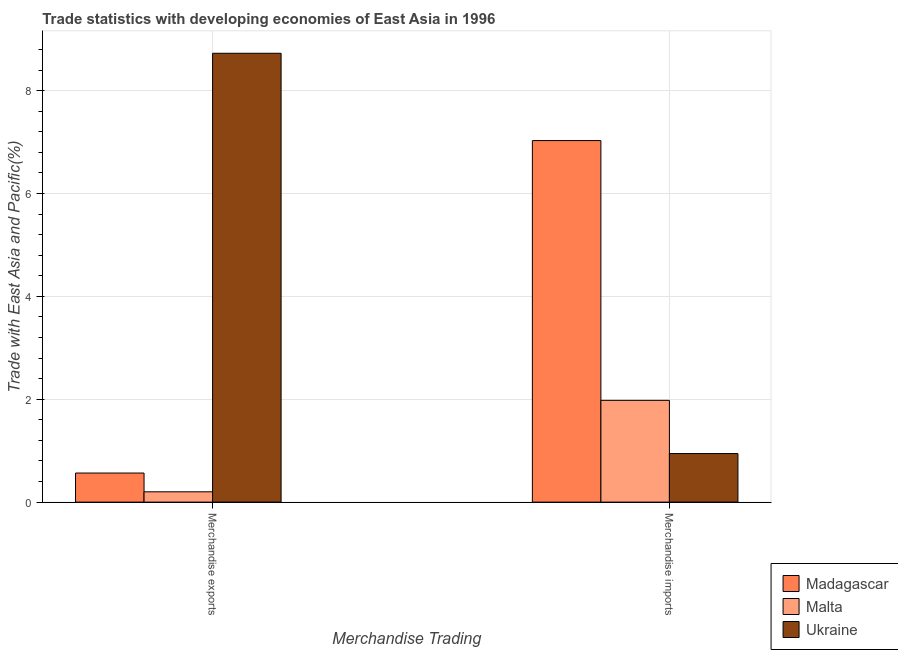How many groups of bars are there?
Offer a terse response. 2. What is the merchandise exports in Madagascar?
Offer a terse response. 0.57. Across all countries, what is the maximum merchandise imports?
Your response must be concise. 7.03. Across all countries, what is the minimum merchandise imports?
Your answer should be compact. 0.94. In which country was the merchandise imports maximum?
Make the answer very short. Madagascar. In which country was the merchandise imports minimum?
Make the answer very short. Ukraine. What is the total merchandise exports in the graph?
Offer a terse response. 9.49. What is the difference between the merchandise imports in Ukraine and that in Madagascar?
Your response must be concise. -6.09. What is the difference between the merchandise imports in Ukraine and the merchandise exports in Malta?
Provide a succinct answer. 0.74. What is the average merchandise imports per country?
Offer a terse response. 3.32. What is the difference between the merchandise imports and merchandise exports in Madagascar?
Provide a short and direct response. 6.46. What is the ratio of the merchandise exports in Ukraine to that in Madagascar?
Offer a terse response. 15.43. In how many countries, is the merchandise exports greater than the average merchandise exports taken over all countries?
Keep it short and to the point. 1. What does the 1st bar from the left in Merchandise imports represents?
Keep it short and to the point. Madagascar. What does the 3rd bar from the right in Merchandise exports represents?
Offer a very short reply. Madagascar. How many bars are there?
Provide a short and direct response. 6. How many countries are there in the graph?
Ensure brevity in your answer.  3. Are the values on the major ticks of Y-axis written in scientific E-notation?
Your answer should be compact. No. Does the graph contain grids?
Make the answer very short. Yes. Where does the legend appear in the graph?
Offer a very short reply. Bottom right. How are the legend labels stacked?
Offer a very short reply. Vertical. What is the title of the graph?
Keep it short and to the point. Trade statistics with developing economies of East Asia in 1996. What is the label or title of the X-axis?
Your answer should be compact. Merchandise Trading. What is the label or title of the Y-axis?
Provide a short and direct response. Trade with East Asia and Pacific(%). What is the Trade with East Asia and Pacific(%) in Madagascar in Merchandise exports?
Ensure brevity in your answer.  0.57. What is the Trade with East Asia and Pacific(%) in Malta in Merchandise exports?
Your answer should be very brief. 0.2. What is the Trade with East Asia and Pacific(%) of Ukraine in Merchandise exports?
Your response must be concise. 8.73. What is the Trade with East Asia and Pacific(%) in Madagascar in Merchandise imports?
Provide a succinct answer. 7.03. What is the Trade with East Asia and Pacific(%) in Malta in Merchandise imports?
Provide a succinct answer. 1.98. What is the Trade with East Asia and Pacific(%) of Ukraine in Merchandise imports?
Your response must be concise. 0.94. Across all Merchandise Trading, what is the maximum Trade with East Asia and Pacific(%) of Madagascar?
Your answer should be very brief. 7.03. Across all Merchandise Trading, what is the maximum Trade with East Asia and Pacific(%) of Malta?
Your answer should be compact. 1.98. Across all Merchandise Trading, what is the maximum Trade with East Asia and Pacific(%) of Ukraine?
Offer a terse response. 8.73. Across all Merchandise Trading, what is the minimum Trade with East Asia and Pacific(%) in Madagascar?
Offer a terse response. 0.57. Across all Merchandise Trading, what is the minimum Trade with East Asia and Pacific(%) in Malta?
Your answer should be compact. 0.2. Across all Merchandise Trading, what is the minimum Trade with East Asia and Pacific(%) of Ukraine?
Your answer should be compact. 0.94. What is the total Trade with East Asia and Pacific(%) of Madagascar in the graph?
Provide a succinct answer. 7.6. What is the total Trade with East Asia and Pacific(%) of Malta in the graph?
Your answer should be very brief. 2.18. What is the total Trade with East Asia and Pacific(%) in Ukraine in the graph?
Give a very brief answer. 9.67. What is the difference between the Trade with East Asia and Pacific(%) of Madagascar in Merchandise exports and that in Merchandise imports?
Provide a short and direct response. -6.46. What is the difference between the Trade with East Asia and Pacific(%) of Malta in Merchandise exports and that in Merchandise imports?
Offer a terse response. -1.78. What is the difference between the Trade with East Asia and Pacific(%) in Ukraine in Merchandise exports and that in Merchandise imports?
Make the answer very short. 7.78. What is the difference between the Trade with East Asia and Pacific(%) of Madagascar in Merchandise exports and the Trade with East Asia and Pacific(%) of Malta in Merchandise imports?
Ensure brevity in your answer.  -1.41. What is the difference between the Trade with East Asia and Pacific(%) in Madagascar in Merchandise exports and the Trade with East Asia and Pacific(%) in Ukraine in Merchandise imports?
Provide a short and direct response. -0.38. What is the difference between the Trade with East Asia and Pacific(%) of Malta in Merchandise exports and the Trade with East Asia and Pacific(%) of Ukraine in Merchandise imports?
Your response must be concise. -0.74. What is the average Trade with East Asia and Pacific(%) of Madagascar per Merchandise Trading?
Provide a short and direct response. 3.8. What is the average Trade with East Asia and Pacific(%) of Malta per Merchandise Trading?
Your answer should be very brief. 1.09. What is the average Trade with East Asia and Pacific(%) of Ukraine per Merchandise Trading?
Keep it short and to the point. 4.84. What is the difference between the Trade with East Asia and Pacific(%) in Madagascar and Trade with East Asia and Pacific(%) in Malta in Merchandise exports?
Your answer should be very brief. 0.36. What is the difference between the Trade with East Asia and Pacific(%) in Madagascar and Trade with East Asia and Pacific(%) in Ukraine in Merchandise exports?
Provide a succinct answer. -8.16. What is the difference between the Trade with East Asia and Pacific(%) of Malta and Trade with East Asia and Pacific(%) of Ukraine in Merchandise exports?
Your response must be concise. -8.53. What is the difference between the Trade with East Asia and Pacific(%) of Madagascar and Trade with East Asia and Pacific(%) of Malta in Merchandise imports?
Give a very brief answer. 5.05. What is the difference between the Trade with East Asia and Pacific(%) of Madagascar and Trade with East Asia and Pacific(%) of Ukraine in Merchandise imports?
Offer a terse response. 6.08. What is the difference between the Trade with East Asia and Pacific(%) in Malta and Trade with East Asia and Pacific(%) in Ukraine in Merchandise imports?
Keep it short and to the point. 1.03. What is the ratio of the Trade with East Asia and Pacific(%) of Madagascar in Merchandise exports to that in Merchandise imports?
Offer a very short reply. 0.08. What is the ratio of the Trade with East Asia and Pacific(%) of Malta in Merchandise exports to that in Merchandise imports?
Ensure brevity in your answer.  0.1. What is the ratio of the Trade with East Asia and Pacific(%) in Ukraine in Merchandise exports to that in Merchandise imports?
Ensure brevity in your answer.  9.24. What is the difference between the highest and the second highest Trade with East Asia and Pacific(%) in Madagascar?
Your answer should be compact. 6.46. What is the difference between the highest and the second highest Trade with East Asia and Pacific(%) in Malta?
Provide a succinct answer. 1.78. What is the difference between the highest and the second highest Trade with East Asia and Pacific(%) of Ukraine?
Your answer should be very brief. 7.78. What is the difference between the highest and the lowest Trade with East Asia and Pacific(%) in Madagascar?
Offer a very short reply. 6.46. What is the difference between the highest and the lowest Trade with East Asia and Pacific(%) of Malta?
Your answer should be very brief. 1.78. What is the difference between the highest and the lowest Trade with East Asia and Pacific(%) in Ukraine?
Keep it short and to the point. 7.78. 